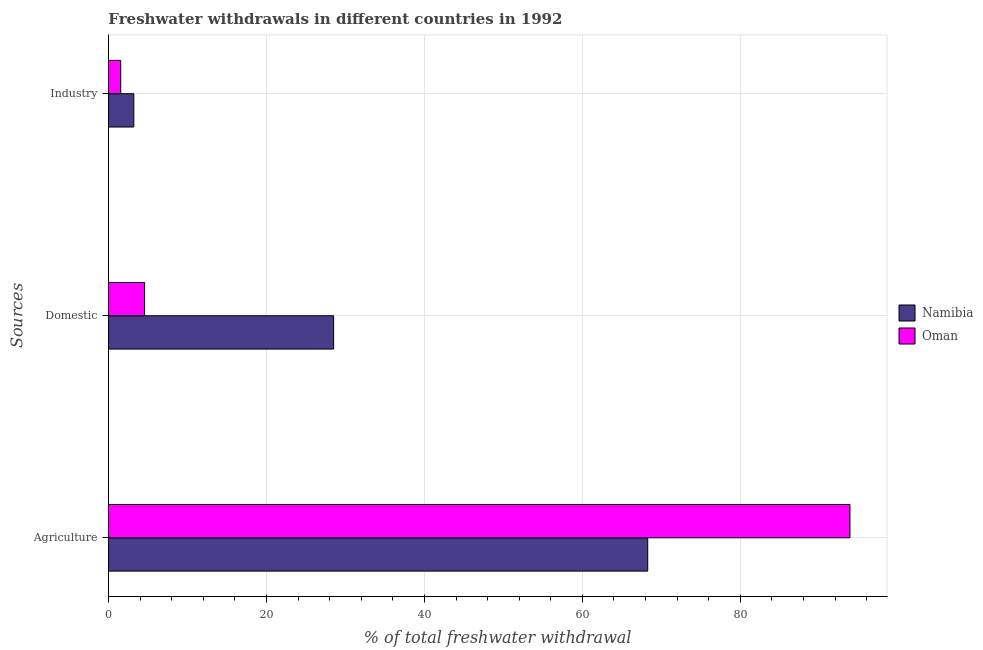How many groups of bars are there?
Your answer should be compact. 3. How many bars are there on the 2nd tick from the bottom?
Your answer should be compact. 2. What is the label of the 1st group of bars from the top?
Offer a very short reply. Industry. What is the percentage of freshwater withdrawal for domestic purposes in Namibia?
Offer a terse response. 28.51. Across all countries, what is the maximum percentage of freshwater withdrawal for agriculture?
Your answer should be compact. 93.87. Across all countries, what is the minimum percentage of freshwater withdrawal for domestic purposes?
Keep it short and to the point. 4.58. In which country was the percentage of freshwater withdrawal for industry maximum?
Provide a short and direct response. Namibia. In which country was the percentage of freshwater withdrawal for domestic purposes minimum?
Make the answer very short. Oman. What is the total percentage of freshwater withdrawal for domestic purposes in the graph?
Offer a terse response. 33.09. What is the difference between the percentage of freshwater withdrawal for industry in Oman and that in Namibia?
Your answer should be compact. -1.66. What is the difference between the percentage of freshwater withdrawal for domestic purposes in Oman and the percentage of freshwater withdrawal for agriculture in Namibia?
Keep it short and to the point. -63.69. What is the average percentage of freshwater withdrawal for agriculture per country?
Offer a terse response. 81.07. What is the difference between the percentage of freshwater withdrawal for domestic purposes and percentage of freshwater withdrawal for industry in Oman?
Provide a succinct answer. 3.02. What is the ratio of the percentage of freshwater withdrawal for agriculture in Namibia to that in Oman?
Your response must be concise. 0.73. Is the percentage of freshwater withdrawal for domestic purposes in Namibia less than that in Oman?
Provide a succinct answer. No. Is the difference between the percentage of freshwater withdrawal for industry in Namibia and Oman greater than the difference between the percentage of freshwater withdrawal for domestic purposes in Namibia and Oman?
Ensure brevity in your answer.  No. What is the difference between the highest and the second highest percentage of freshwater withdrawal for domestic purposes?
Provide a short and direct response. 23.93. What is the difference between the highest and the lowest percentage of freshwater withdrawal for industry?
Your response must be concise. 1.66. In how many countries, is the percentage of freshwater withdrawal for agriculture greater than the average percentage of freshwater withdrawal for agriculture taken over all countries?
Your answer should be very brief. 1. What does the 2nd bar from the top in Agriculture represents?
Offer a terse response. Namibia. What does the 2nd bar from the bottom in Industry represents?
Provide a short and direct response. Oman. How many countries are there in the graph?
Give a very brief answer. 2. Does the graph contain any zero values?
Give a very brief answer. No. Does the graph contain grids?
Your answer should be very brief. Yes. Where does the legend appear in the graph?
Ensure brevity in your answer.  Center right. How are the legend labels stacked?
Provide a succinct answer. Vertical. What is the title of the graph?
Your answer should be very brief. Freshwater withdrawals in different countries in 1992. Does "Papua New Guinea" appear as one of the legend labels in the graph?
Give a very brief answer. No. What is the label or title of the X-axis?
Offer a very short reply. % of total freshwater withdrawal. What is the label or title of the Y-axis?
Your response must be concise. Sources. What is the % of total freshwater withdrawal in Namibia in Agriculture?
Give a very brief answer. 68.27. What is the % of total freshwater withdrawal in Oman in Agriculture?
Ensure brevity in your answer.  93.87. What is the % of total freshwater withdrawal of Namibia in Domestic?
Provide a succinct answer. 28.51. What is the % of total freshwater withdrawal of Oman in Domestic?
Your response must be concise. 4.58. What is the % of total freshwater withdrawal of Namibia in Industry?
Ensure brevity in your answer.  3.21. What is the % of total freshwater withdrawal of Oman in Industry?
Your response must be concise. 1.55. Across all Sources, what is the maximum % of total freshwater withdrawal of Namibia?
Ensure brevity in your answer.  68.27. Across all Sources, what is the maximum % of total freshwater withdrawal in Oman?
Offer a very short reply. 93.87. Across all Sources, what is the minimum % of total freshwater withdrawal in Namibia?
Your answer should be compact. 3.21. Across all Sources, what is the minimum % of total freshwater withdrawal of Oman?
Keep it short and to the point. 1.55. What is the total % of total freshwater withdrawal of Namibia in the graph?
Your answer should be very brief. 99.99. What is the total % of total freshwater withdrawal of Oman in the graph?
Your answer should be compact. 100. What is the difference between the % of total freshwater withdrawal in Namibia in Agriculture and that in Domestic?
Give a very brief answer. 39.76. What is the difference between the % of total freshwater withdrawal of Oman in Agriculture and that in Domestic?
Your response must be concise. 89.29. What is the difference between the % of total freshwater withdrawal in Namibia in Agriculture and that in Industry?
Make the answer very short. 65.06. What is the difference between the % of total freshwater withdrawal in Oman in Agriculture and that in Industry?
Ensure brevity in your answer.  92.32. What is the difference between the % of total freshwater withdrawal of Namibia in Domestic and that in Industry?
Your answer should be compact. 25.3. What is the difference between the % of total freshwater withdrawal in Oman in Domestic and that in Industry?
Give a very brief answer. 3.02. What is the difference between the % of total freshwater withdrawal of Namibia in Agriculture and the % of total freshwater withdrawal of Oman in Domestic?
Keep it short and to the point. 63.69. What is the difference between the % of total freshwater withdrawal in Namibia in Agriculture and the % of total freshwater withdrawal in Oman in Industry?
Your response must be concise. 66.72. What is the difference between the % of total freshwater withdrawal in Namibia in Domestic and the % of total freshwater withdrawal in Oman in Industry?
Your answer should be compact. 26.96. What is the average % of total freshwater withdrawal in Namibia per Sources?
Give a very brief answer. 33.33. What is the average % of total freshwater withdrawal in Oman per Sources?
Offer a terse response. 33.33. What is the difference between the % of total freshwater withdrawal in Namibia and % of total freshwater withdrawal in Oman in Agriculture?
Provide a short and direct response. -25.6. What is the difference between the % of total freshwater withdrawal in Namibia and % of total freshwater withdrawal in Oman in Domestic?
Keep it short and to the point. 23.93. What is the difference between the % of total freshwater withdrawal of Namibia and % of total freshwater withdrawal of Oman in Industry?
Your answer should be compact. 1.66. What is the ratio of the % of total freshwater withdrawal in Namibia in Agriculture to that in Domestic?
Keep it short and to the point. 2.39. What is the ratio of the % of total freshwater withdrawal in Oman in Agriculture to that in Domestic?
Offer a terse response. 20.5. What is the ratio of the % of total freshwater withdrawal in Namibia in Agriculture to that in Industry?
Your answer should be compact. 21.25. What is the ratio of the % of total freshwater withdrawal in Oman in Agriculture to that in Industry?
Your response must be concise. 60.41. What is the ratio of the % of total freshwater withdrawal of Namibia in Domestic to that in Industry?
Your answer should be very brief. 8.87. What is the ratio of the % of total freshwater withdrawal of Oman in Domestic to that in Industry?
Make the answer very short. 2.95. What is the difference between the highest and the second highest % of total freshwater withdrawal of Namibia?
Provide a succinct answer. 39.76. What is the difference between the highest and the second highest % of total freshwater withdrawal in Oman?
Give a very brief answer. 89.29. What is the difference between the highest and the lowest % of total freshwater withdrawal in Namibia?
Provide a succinct answer. 65.06. What is the difference between the highest and the lowest % of total freshwater withdrawal of Oman?
Your answer should be compact. 92.32. 